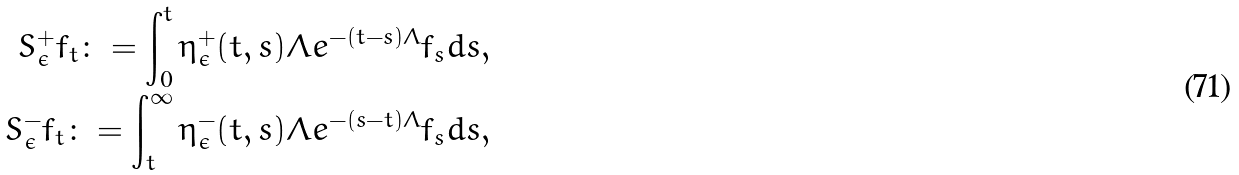<formula> <loc_0><loc_0><loc_500><loc_500>S ^ { + } _ { \epsilon } f _ { t } \colon = \int _ { 0 } ^ { t } \eta _ { \epsilon } ^ { + } ( t , s ) \Lambda e ^ { - ( t - s ) \Lambda } f _ { s } d s , \\ S ^ { - } _ { \epsilon } f _ { t } \colon = \int _ { t } ^ { \infty } \eta _ { \epsilon } ^ { - } ( t , s ) \Lambda e ^ { - ( s - t ) \Lambda } f _ { s } d s ,</formula> 